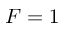Convert formula to latex. <formula><loc_0><loc_0><loc_500><loc_500>F = 1</formula> 